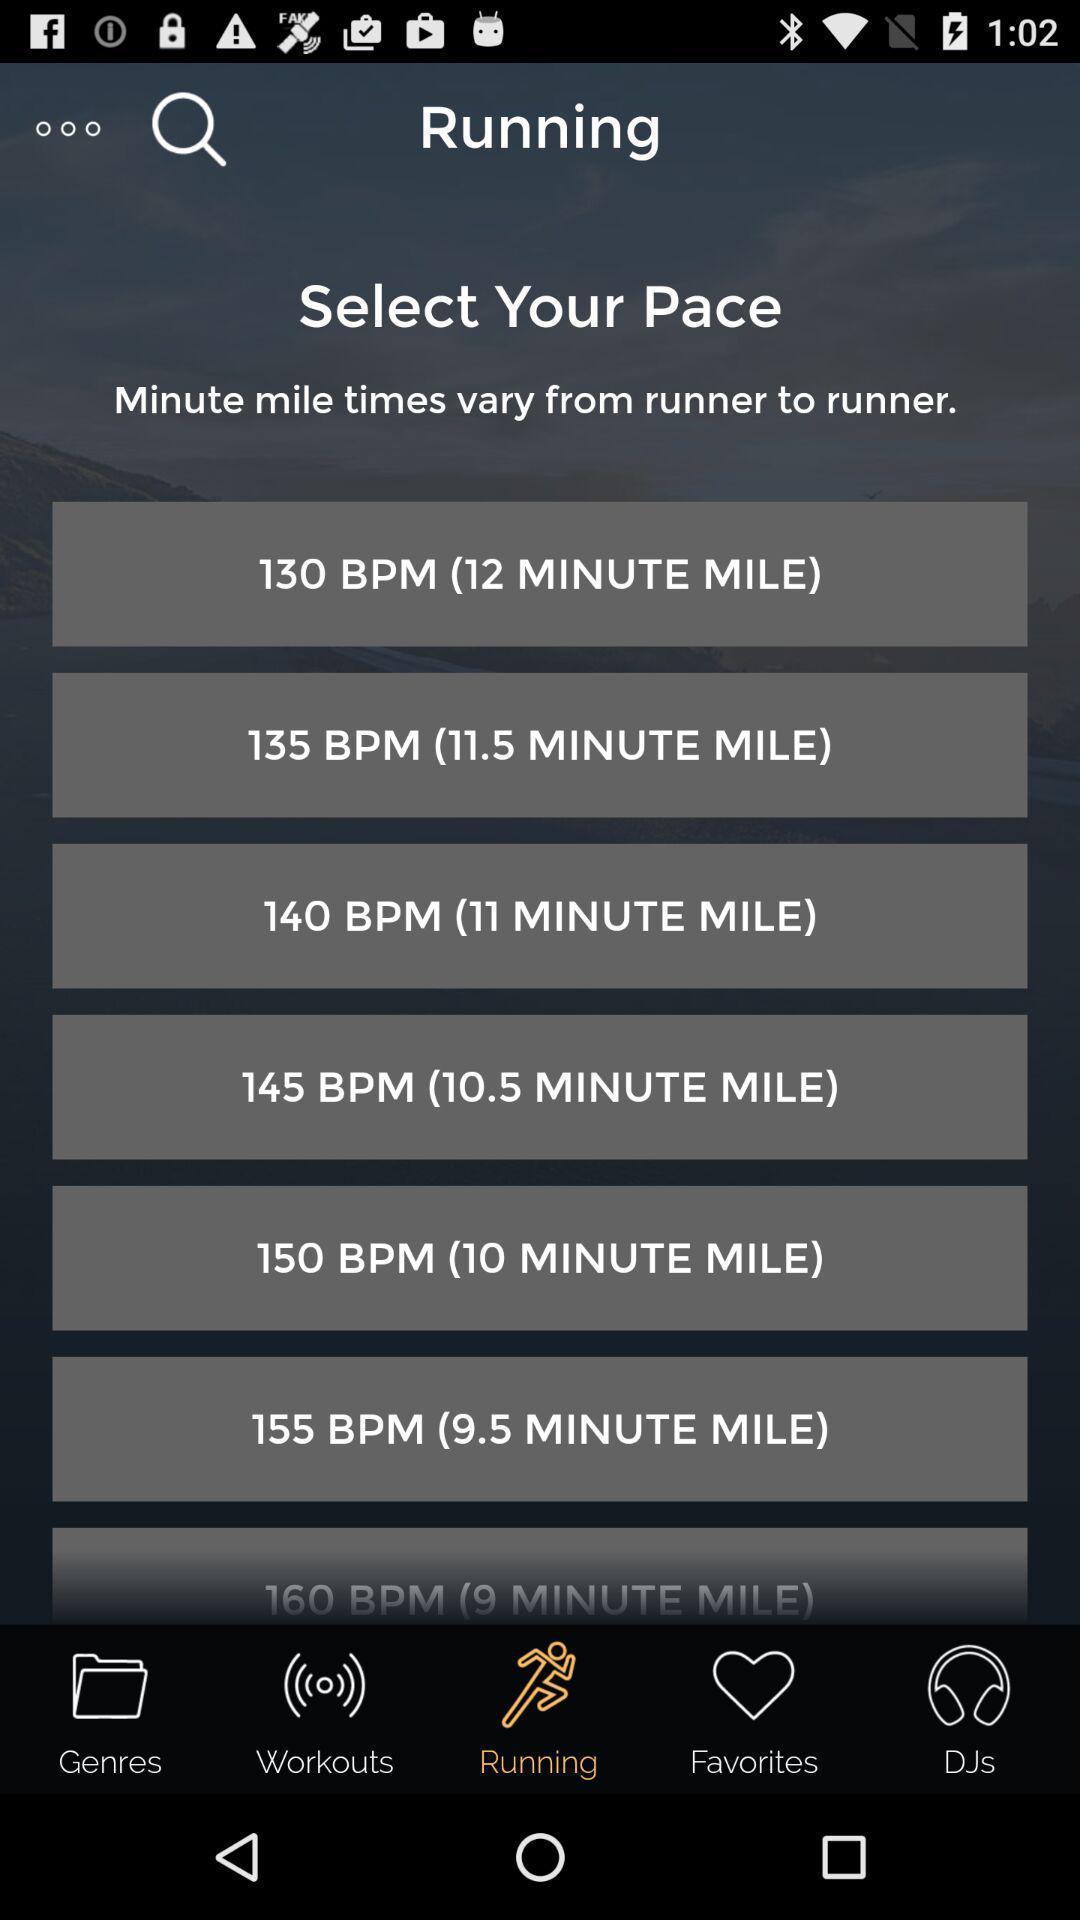Please provide a description for this image. Screen showing list of various distances in a workout app. 